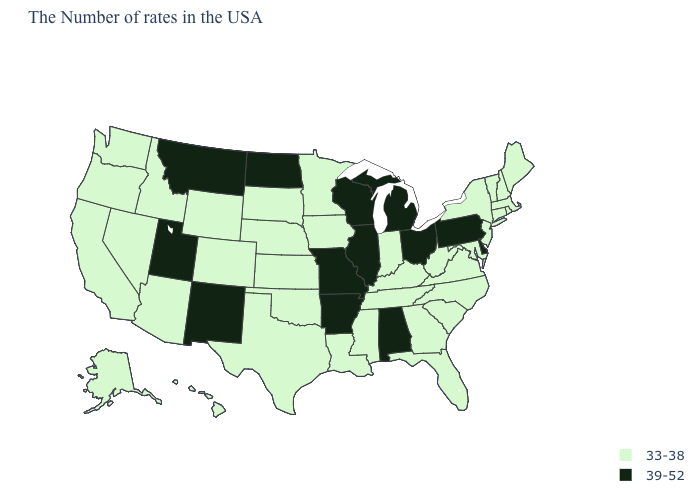What is the value of Florida?
Be succinct. 33-38. Among the states that border Tennessee , which have the highest value?
Quick response, please. Alabama, Missouri, Arkansas. Which states have the lowest value in the West?
Be succinct. Wyoming, Colorado, Arizona, Idaho, Nevada, California, Washington, Oregon, Alaska, Hawaii. Name the states that have a value in the range 39-52?
Concise answer only. Delaware, Pennsylvania, Ohio, Michigan, Alabama, Wisconsin, Illinois, Missouri, Arkansas, North Dakota, New Mexico, Utah, Montana. Among the states that border North Dakota , which have the highest value?
Be succinct. Montana. Name the states that have a value in the range 33-38?
Concise answer only. Maine, Massachusetts, Rhode Island, New Hampshire, Vermont, Connecticut, New York, New Jersey, Maryland, Virginia, North Carolina, South Carolina, West Virginia, Florida, Georgia, Kentucky, Indiana, Tennessee, Mississippi, Louisiana, Minnesota, Iowa, Kansas, Nebraska, Oklahoma, Texas, South Dakota, Wyoming, Colorado, Arizona, Idaho, Nevada, California, Washington, Oregon, Alaska, Hawaii. Name the states that have a value in the range 33-38?
Concise answer only. Maine, Massachusetts, Rhode Island, New Hampshire, Vermont, Connecticut, New York, New Jersey, Maryland, Virginia, North Carolina, South Carolina, West Virginia, Florida, Georgia, Kentucky, Indiana, Tennessee, Mississippi, Louisiana, Minnesota, Iowa, Kansas, Nebraska, Oklahoma, Texas, South Dakota, Wyoming, Colorado, Arizona, Idaho, Nevada, California, Washington, Oregon, Alaska, Hawaii. What is the lowest value in the MidWest?
Short answer required. 33-38. What is the value of Florida?
Be succinct. 33-38. Does Iowa have a lower value than New Hampshire?
Concise answer only. No. Name the states that have a value in the range 33-38?
Concise answer only. Maine, Massachusetts, Rhode Island, New Hampshire, Vermont, Connecticut, New York, New Jersey, Maryland, Virginia, North Carolina, South Carolina, West Virginia, Florida, Georgia, Kentucky, Indiana, Tennessee, Mississippi, Louisiana, Minnesota, Iowa, Kansas, Nebraska, Oklahoma, Texas, South Dakota, Wyoming, Colorado, Arizona, Idaho, Nevada, California, Washington, Oregon, Alaska, Hawaii. Name the states that have a value in the range 33-38?
Short answer required. Maine, Massachusetts, Rhode Island, New Hampshire, Vermont, Connecticut, New York, New Jersey, Maryland, Virginia, North Carolina, South Carolina, West Virginia, Florida, Georgia, Kentucky, Indiana, Tennessee, Mississippi, Louisiana, Minnesota, Iowa, Kansas, Nebraska, Oklahoma, Texas, South Dakota, Wyoming, Colorado, Arizona, Idaho, Nevada, California, Washington, Oregon, Alaska, Hawaii. Among the states that border Indiana , which have the highest value?
Answer briefly. Ohio, Michigan, Illinois. Is the legend a continuous bar?
Quick response, please. No. What is the highest value in the West ?
Quick response, please. 39-52. 